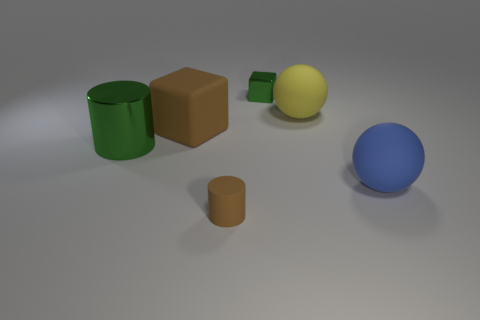Are there more small yellow rubber cylinders than blue balls?
Ensure brevity in your answer.  No. What size is the thing that is the same color as the shiny cylinder?
Offer a very short reply. Small. What is the shape of the metal thing that is behind the matte ball that is behind the shiny cylinder?
Provide a short and direct response. Cube. Is there a large rubber sphere that is in front of the block that is to the left of the small thing in front of the tiny metallic thing?
Keep it short and to the point. Yes. The thing that is the same size as the brown cylinder is what color?
Your answer should be compact. Green. There is a matte thing that is to the right of the large brown object and left of the yellow matte ball; what is its shape?
Make the answer very short. Cylinder. There is a green metallic object that is right of the green thing on the left side of the tiny metal cube; what size is it?
Ensure brevity in your answer.  Small. How many small matte cylinders are the same color as the large rubber cube?
Your answer should be compact. 1. How many other objects are the same size as the yellow rubber thing?
Give a very brief answer. 3. There is a rubber thing that is behind the blue rubber sphere and to the right of the rubber cylinder; what is its size?
Offer a very short reply. Large. 